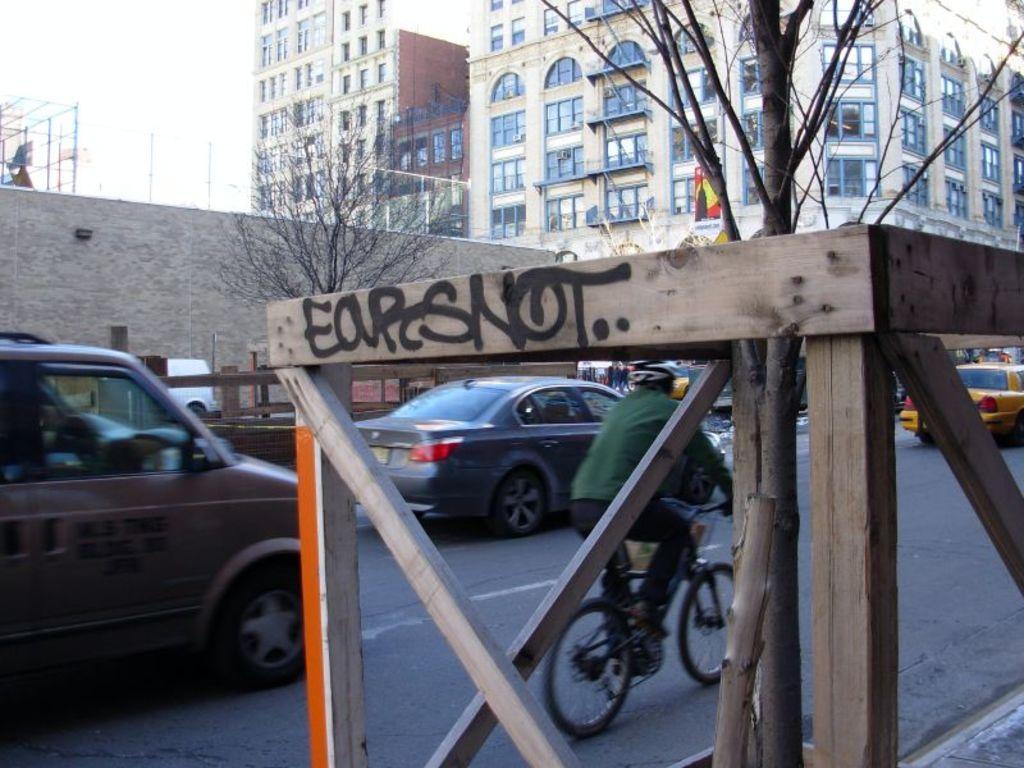Describe this image in one or two sentences. In this image we can see some vehicles on the road and a person riding bicycle. We can also see some trees, buildings with windows and the sky which looks cloudy. 